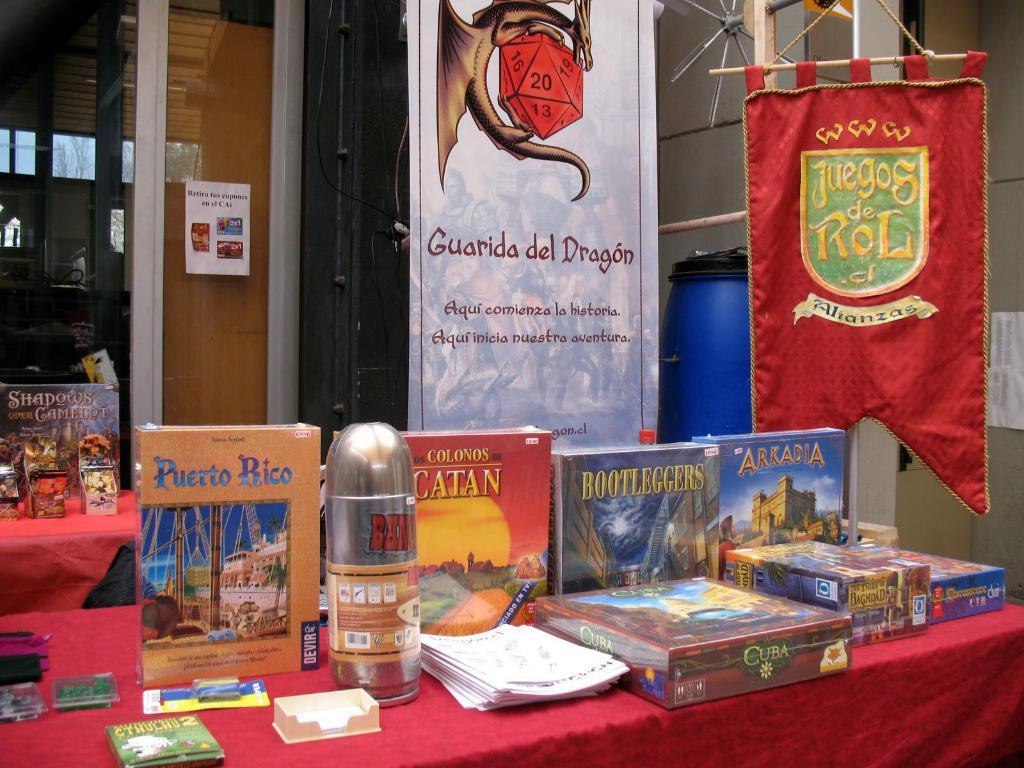<image>
Give a short and clear explanation of the subsequent image. Items for sale on a table at Juegos de Rol. 